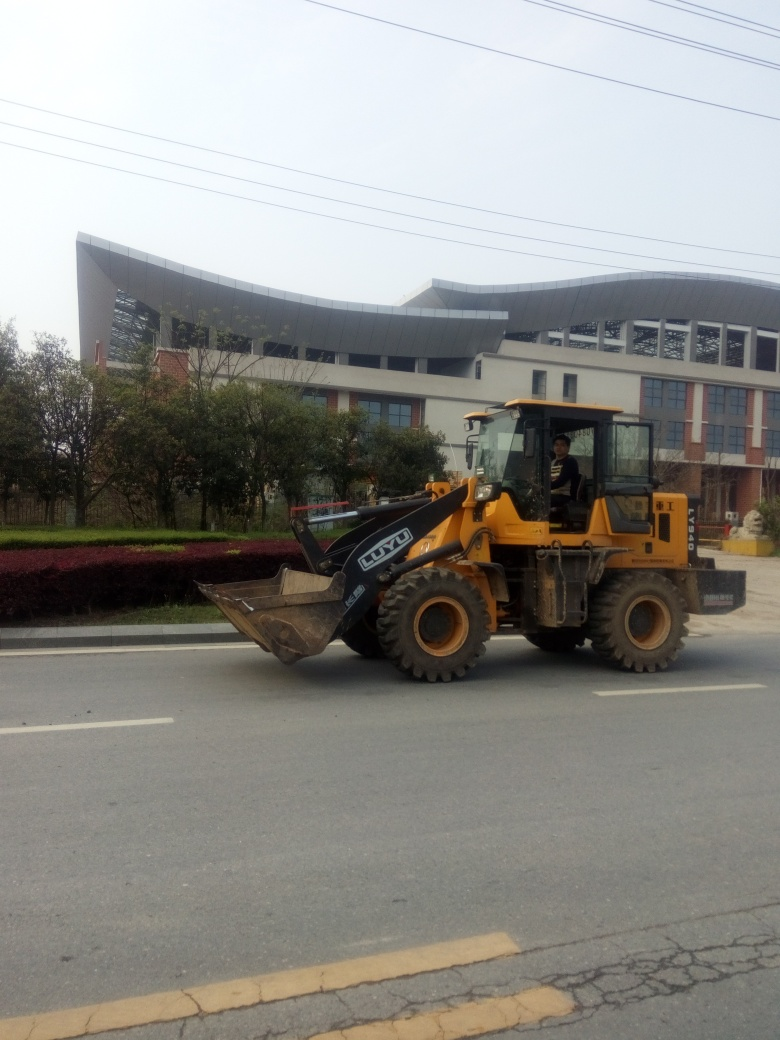What type of vehicle is prominent in the image? The image prominently features a front loader, which is a type of heavy equipment used in construction to move aside or load materials such as asphalt, demolition debris, dirt, snow, feed, gravel, logs, raw minerals, recycled material, rock, sand, woodchips, etc. Can you give more details about the surroundings? Certainly! The background shows a modern building with a distinct architectural design characterized by large glass windows and a curved structure. There are power lines visible above, along with lush green trees, indicating an urban or semi-urban environment. 